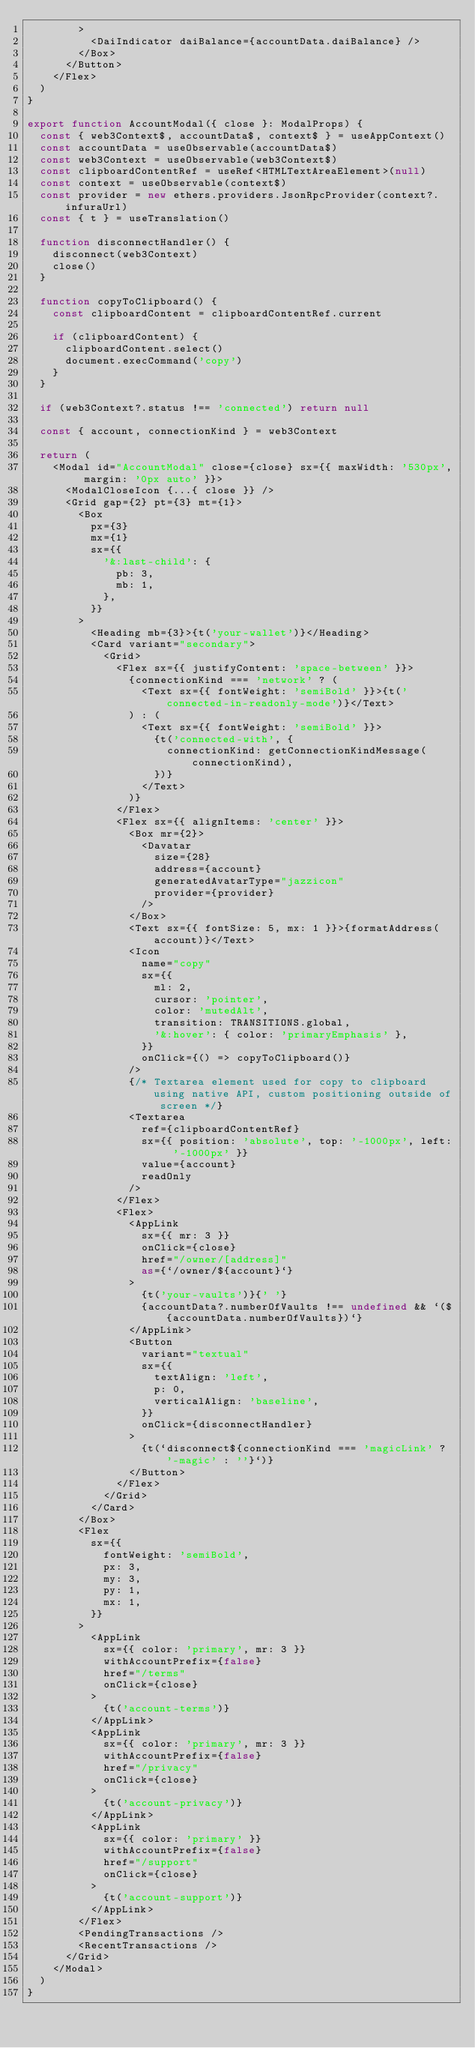<code> <loc_0><loc_0><loc_500><loc_500><_TypeScript_>        >
          <DaiIndicator daiBalance={accountData.daiBalance} />
        </Box>
      </Button>
    </Flex>
  )
}

export function AccountModal({ close }: ModalProps) {
  const { web3Context$, accountData$, context$ } = useAppContext()
  const accountData = useObservable(accountData$)
  const web3Context = useObservable(web3Context$)
  const clipboardContentRef = useRef<HTMLTextAreaElement>(null)
  const context = useObservable(context$)
  const provider = new ethers.providers.JsonRpcProvider(context?.infuraUrl)
  const { t } = useTranslation()

  function disconnectHandler() {
    disconnect(web3Context)
    close()
  }

  function copyToClipboard() {
    const clipboardContent = clipboardContentRef.current

    if (clipboardContent) {
      clipboardContent.select()
      document.execCommand('copy')
    }
  }

  if (web3Context?.status !== 'connected') return null

  const { account, connectionKind } = web3Context

  return (
    <Modal id="AccountModal" close={close} sx={{ maxWidth: '530px', margin: '0px auto' }}>
      <ModalCloseIcon {...{ close }} />
      <Grid gap={2} pt={3} mt={1}>
        <Box
          px={3}
          mx={1}
          sx={{
            '&:last-child': {
              pb: 3,
              mb: 1,
            },
          }}
        >
          <Heading mb={3}>{t('your-wallet')}</Heading>
          <Card variant="secondary">
            <Grid>
              <Flex sx={{ justifyContent: 'space-between' }}>
                {connectionKind === 'network' ? (
                  <Text sx={{ fontWeight: 'semiBold' }}>{t('connected-in-readonly-mode')}</Text>
                ) : (
                  <Text sx={{ fontWeight: 'semiBold' }}>
                    {t('connected-with', {
                      connectionKind: getConnectionKindMessage(connectionKind),
                    })}
                  </Text>
                )}
              </Flex>
              <Flex sx={{ alignItems: 'center' }}>
                <Box mr={2}>
                  <Davatar
                    size={28}
                    address={account}
                    generatedAvatarType="jazzicon"
                    provider={provider}
                  />
                </Box>
                <Text sx={{ fontSize: 5, mx: 1 }}>{formatAddress(account)}</Text>
                <Icon
                  name="copy"
                  sx={{
                    ml: 2,
                    cursor: 'pointer',
                    color: 'mutedAlt',
                    transition: TRANSITIONS.global,
                    '&:hover': { color: 'primaryEmphasis' },
                  }}
                  onClick={() => copyToClipboard()}
                />
                {/* Textarea element used for copy to clipboard using native API, custom positioning outside of screen */}
                <Textarea
                  ref={clipboardContentRef}
                  sx={{ position: 'absolute', top: '-1000px', left: '-1000px' }}
                  value={account}
                  readOnly
                />
              </Flex>
              <Flex>
                <AppLink
                  sx={{ mr: 3 }}
                  onClick={close}
                  href="/owner/[address]"
                  as={`/owner/${account}`}
                >
                  {t('your-vaults')}{' '}
                  {accountData?.numberOfVaults !== undefined && `(${accountData.numberOfVaults})`}
                </AppLink>
                <Button
                  variant="textual"
                  sx={{
                    textAlign: 'left',
                    p: 0,
                    verticalAlign: 'baseline',
                  }}
                  onClick={disconnectHandler}
                >
                  {t(`disconnect${connectionKind === 'magicLink' ? '-magic' : ''}`)}
                </Button>
              </Flex>
            </Grid>
          </Card>
        </Box>
        <Flex
          sx={{
            fontWeight: 'semiBold',
            px: 3,
            my: 3,
            py: 1,
            mx: 1,
          }}
        >
          <AppLink
            sx={{ color: 'primary', mr: 3 }}
            withAccountPrefix={false}
            href="/terms"
            onClick={close}
          >
            {t('account-terms')}
          </AppLink>
          <AppLink
            sx={{ color: 'primary', mr: 3 }}
            withAccountPrefix={false}
            href="/privacy"
            onClick={close}
          >
            {t('account-privacy')}
          </AppLink>
          <AppLink
            sx={{ color: 'primary' }}
            withAccountPrefix={false}
            href="/support"
            onClick={close}
          >
            {t('account-support')}
          </AppLink>
        </Flex>
        <PendingTransactions />
        <RecentTransactions />
      </Grid>
    </Modal>
  )
}
</code> 